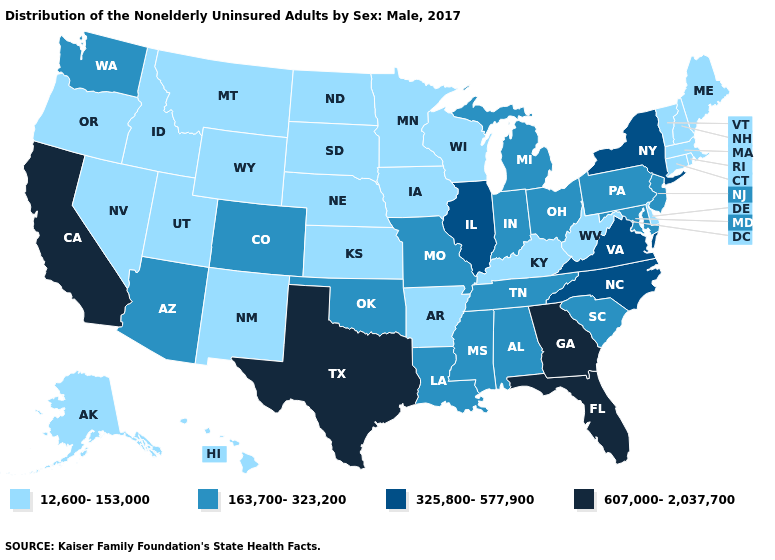Among the states that border Idaho , does Washington have the lowest value?
Short answer required. No. Does Idaho have the highest value in the USA?
Be succinct. No. What is the lowest value in the USA?
Quick response, please. 12,600-153,000. Which states have the lowest value in the USA?
Short answer required. Alaska, Arkansas, Connecticut, Delaware, Hawaii, Idaho, Iowa, Kansas, Kentucky, Maine, Massachusetts, Minnesota, Montana, Nebraska, Nevada, New Hampshire, New Mexico, North Dakota, Oregon, Rhode Island, South Dakota, Utah, Vermont, West Virginia, Wisconsin, Wyoming. What is the lowest value in the USA?
Write a very short answer. 12,600-153,000. What is the highest value in the USA?
Answer briefly. 607,000-2,037,700. How many symbols are there in the legend?
Be succinct. 4. Which states hav the highest value in the South?
Be succinct. Florida, Georgia, Texas. Does Illinois have a lower value than Texas?
Give a very brief answer. Yes. What is the value of Maine?
Quick response, please. 12,600-153,000. What is the value of Massachusetts?
Write a very short answer. 12,600-153,000. Does Michigan have the same value as North Carolina?
Concise answer only. No. Does Florida have a higher value than Arizona?
Quick response, please. Yes. Is the legend a continuous bar?
Keep it brief. No. 